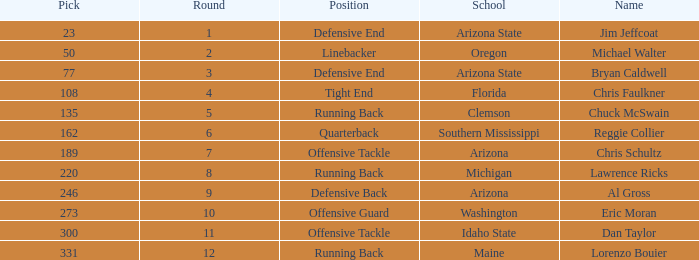What is the position of the player for Washington school? Offensive Guard. 